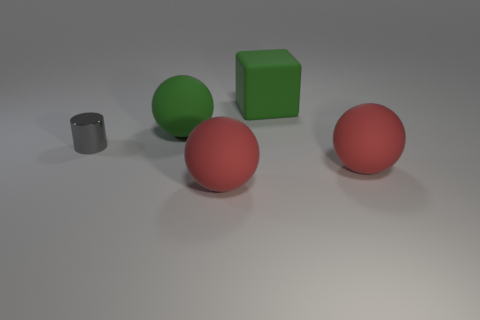Subtract all red rubber balls. How many balls are left? 1 Subtract all red cylinders. How many red balls are left? 2 Add 4 balls. How many objects exist? 9 Subtract all green spheres. How many spheres are left? 2 Subtract all spheres. How many objects are left? 2 Subtract 1 cylinders. How many cylinders are left? 0 Add 3 large green rubber balls. How many large green rubber balls are left? 4 Add 1 large blue metal things. How many large blue metal things exist? 1 Subtract 0 green cylinders. How many objects are left? 5 Subtract all cyan cubes. Subtract all gray cylinders. How many cubes are left? 1 